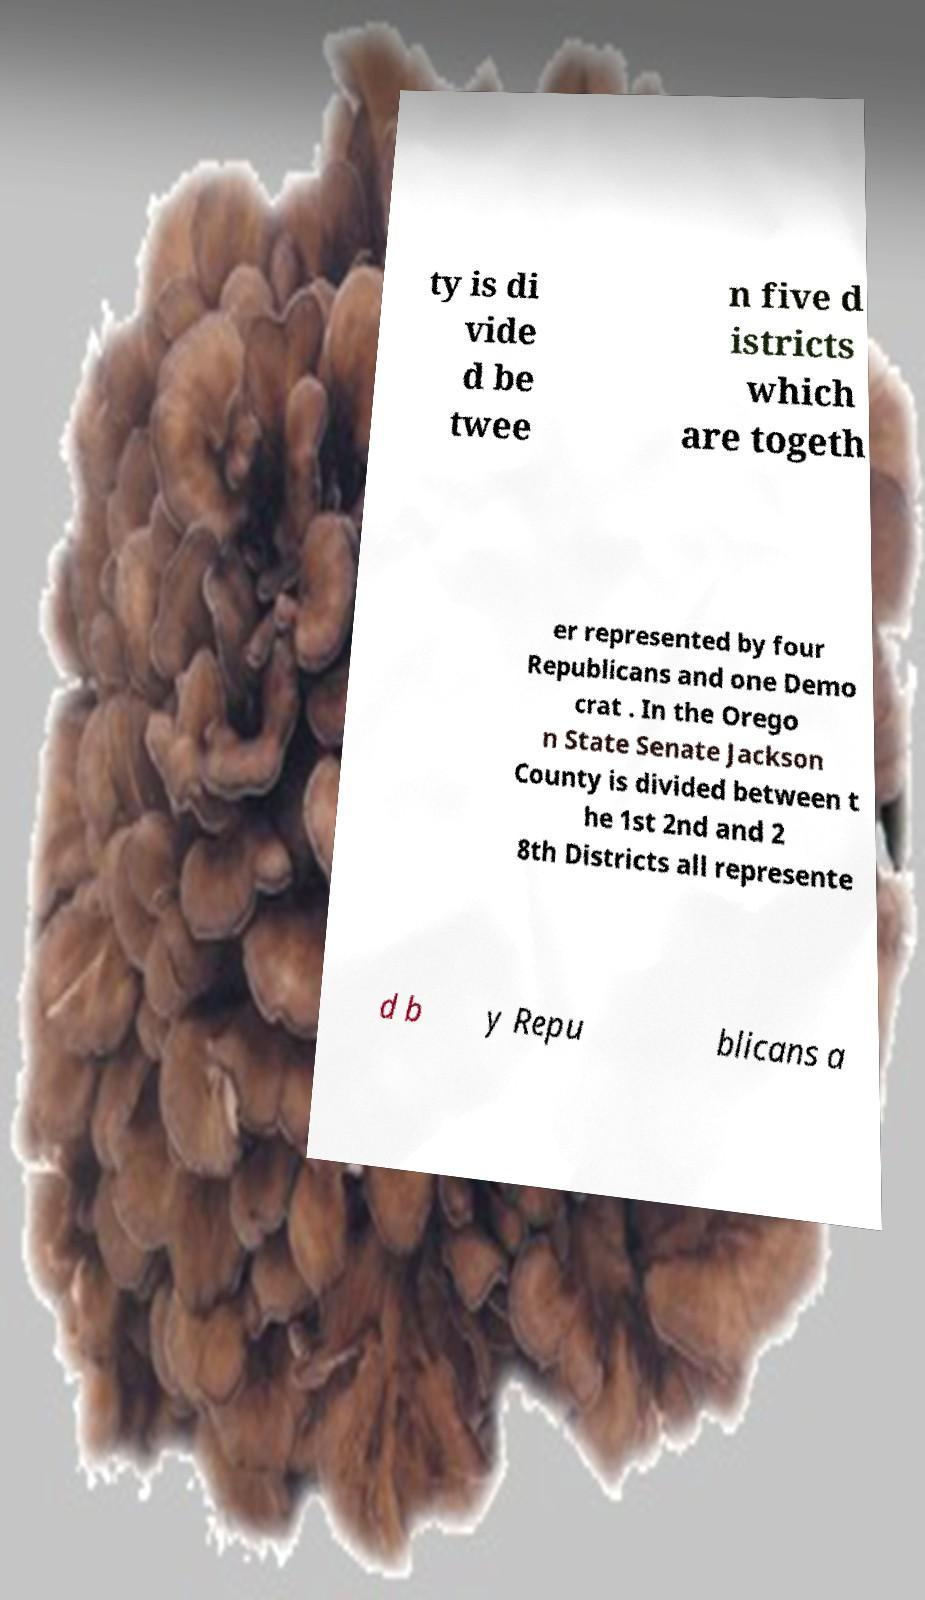I need the written content from this picture converted into text. Can you do that? ty is di vide d be twee n five d istricts which are togeth er represented by four Republicans and one Demo crat . In the Orego n State Senate Jackson County is divided between t he 1st 2nd and 2 8th Districts all represente d b y Repu blicans a 